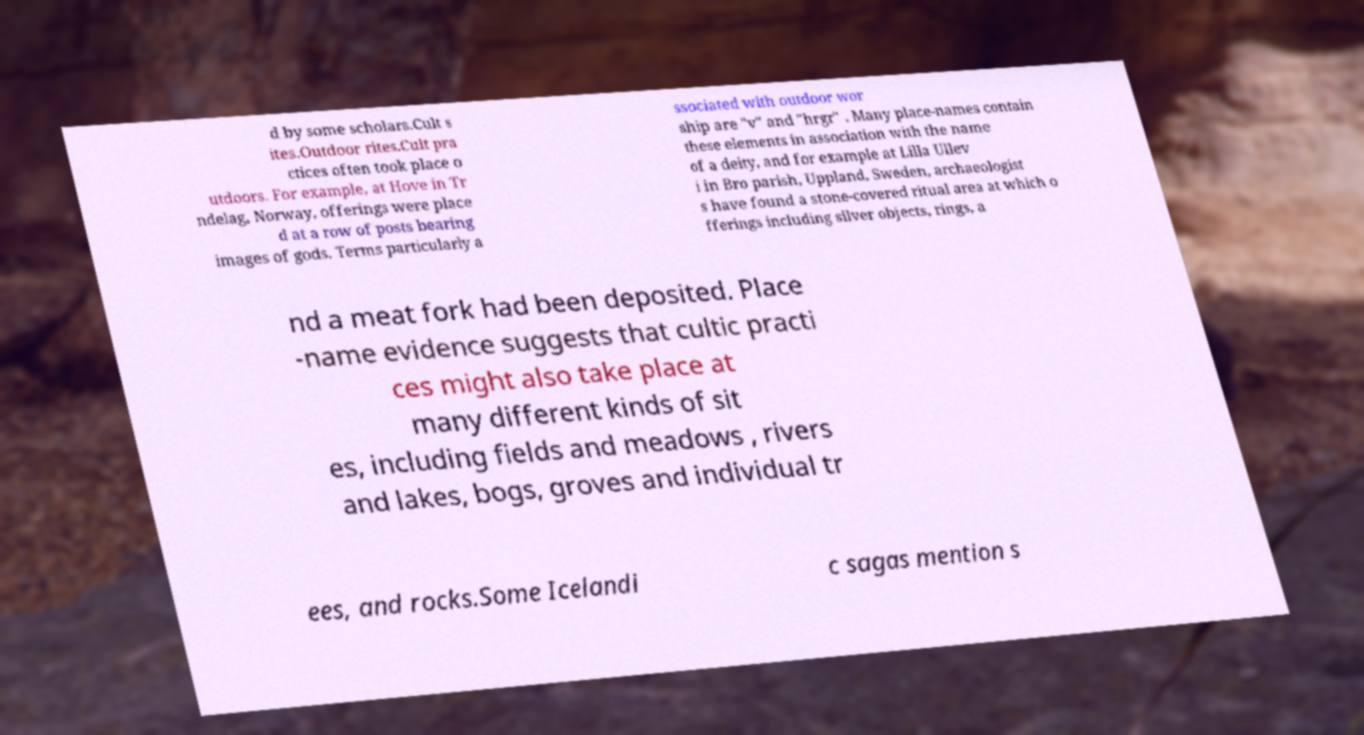Please read and relay the text visible in this image. What does it say? d by some scholars.Cult s ites.Outdoor rites.Cult pra ctices often took place o utdoors. For example, at Hove in Tr ndelag, Norway, offerings were place d at a row of posts bearing images of gods. Terms particularly a ssociated with outdoor wor ship are "v" and "hrgr" . Many place-names contain these elements in association with the name of a deity, and for example at Lilla Ullev i in Bro parish, Uppland, Sweden, archaeologist s have found a stone-covered ritual area at which o fferings including silver objects, rings, a nd a meat fork had been deposited. Place -name evidence suggests that cultic practi ces might also take place at many different kinds of sit es, including fields and meadows , rivers and lakes, bogs, groves and individual tr ees, and rocks.Some Icelandi c sagas mention s 